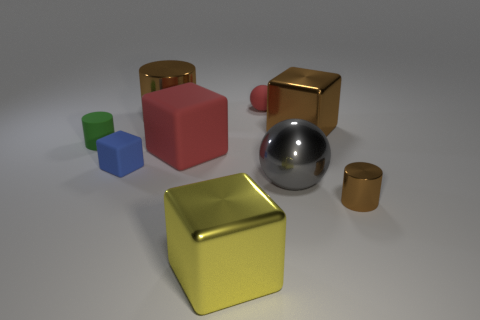There is a large cube that is behind the small shiny cylinder and left of the big ball; what is its material?
Offer a very short reply. Rubber. There is a metallic cube right of the tiny red ball; are there any cylinders that are in front of it?
Keep it short and to the point. Yes. How many large matte things have the same color as the small metallic object?
Ensure brevity in your answer.  0. There is a tiny object that is the same color as the large cylinder; what is it made of?
Keep it short and to the point. Metal. Do the big brown cube and the large gray object have the same material?
Provide a short and direct response. Yes. There is a green rubber cylinder; are there any green rubber cylinders in front of it?
Provide a short and direct response. No. The red thing that is behind the shiny cube that is behind the gray thing is made of what material?
Provide a short and direct response. Rubber. What size is the gray thing that is the same shape as the tiny red thing?
Your answer should be very brief. Large. Do the metallic sphere and the matte sphere have the same color?
Make the answer very short. No. There is a large thing that is on the right side of the small red object and behind the small matte cylinder; what is its color?
Give a very brief answer. Brown. 